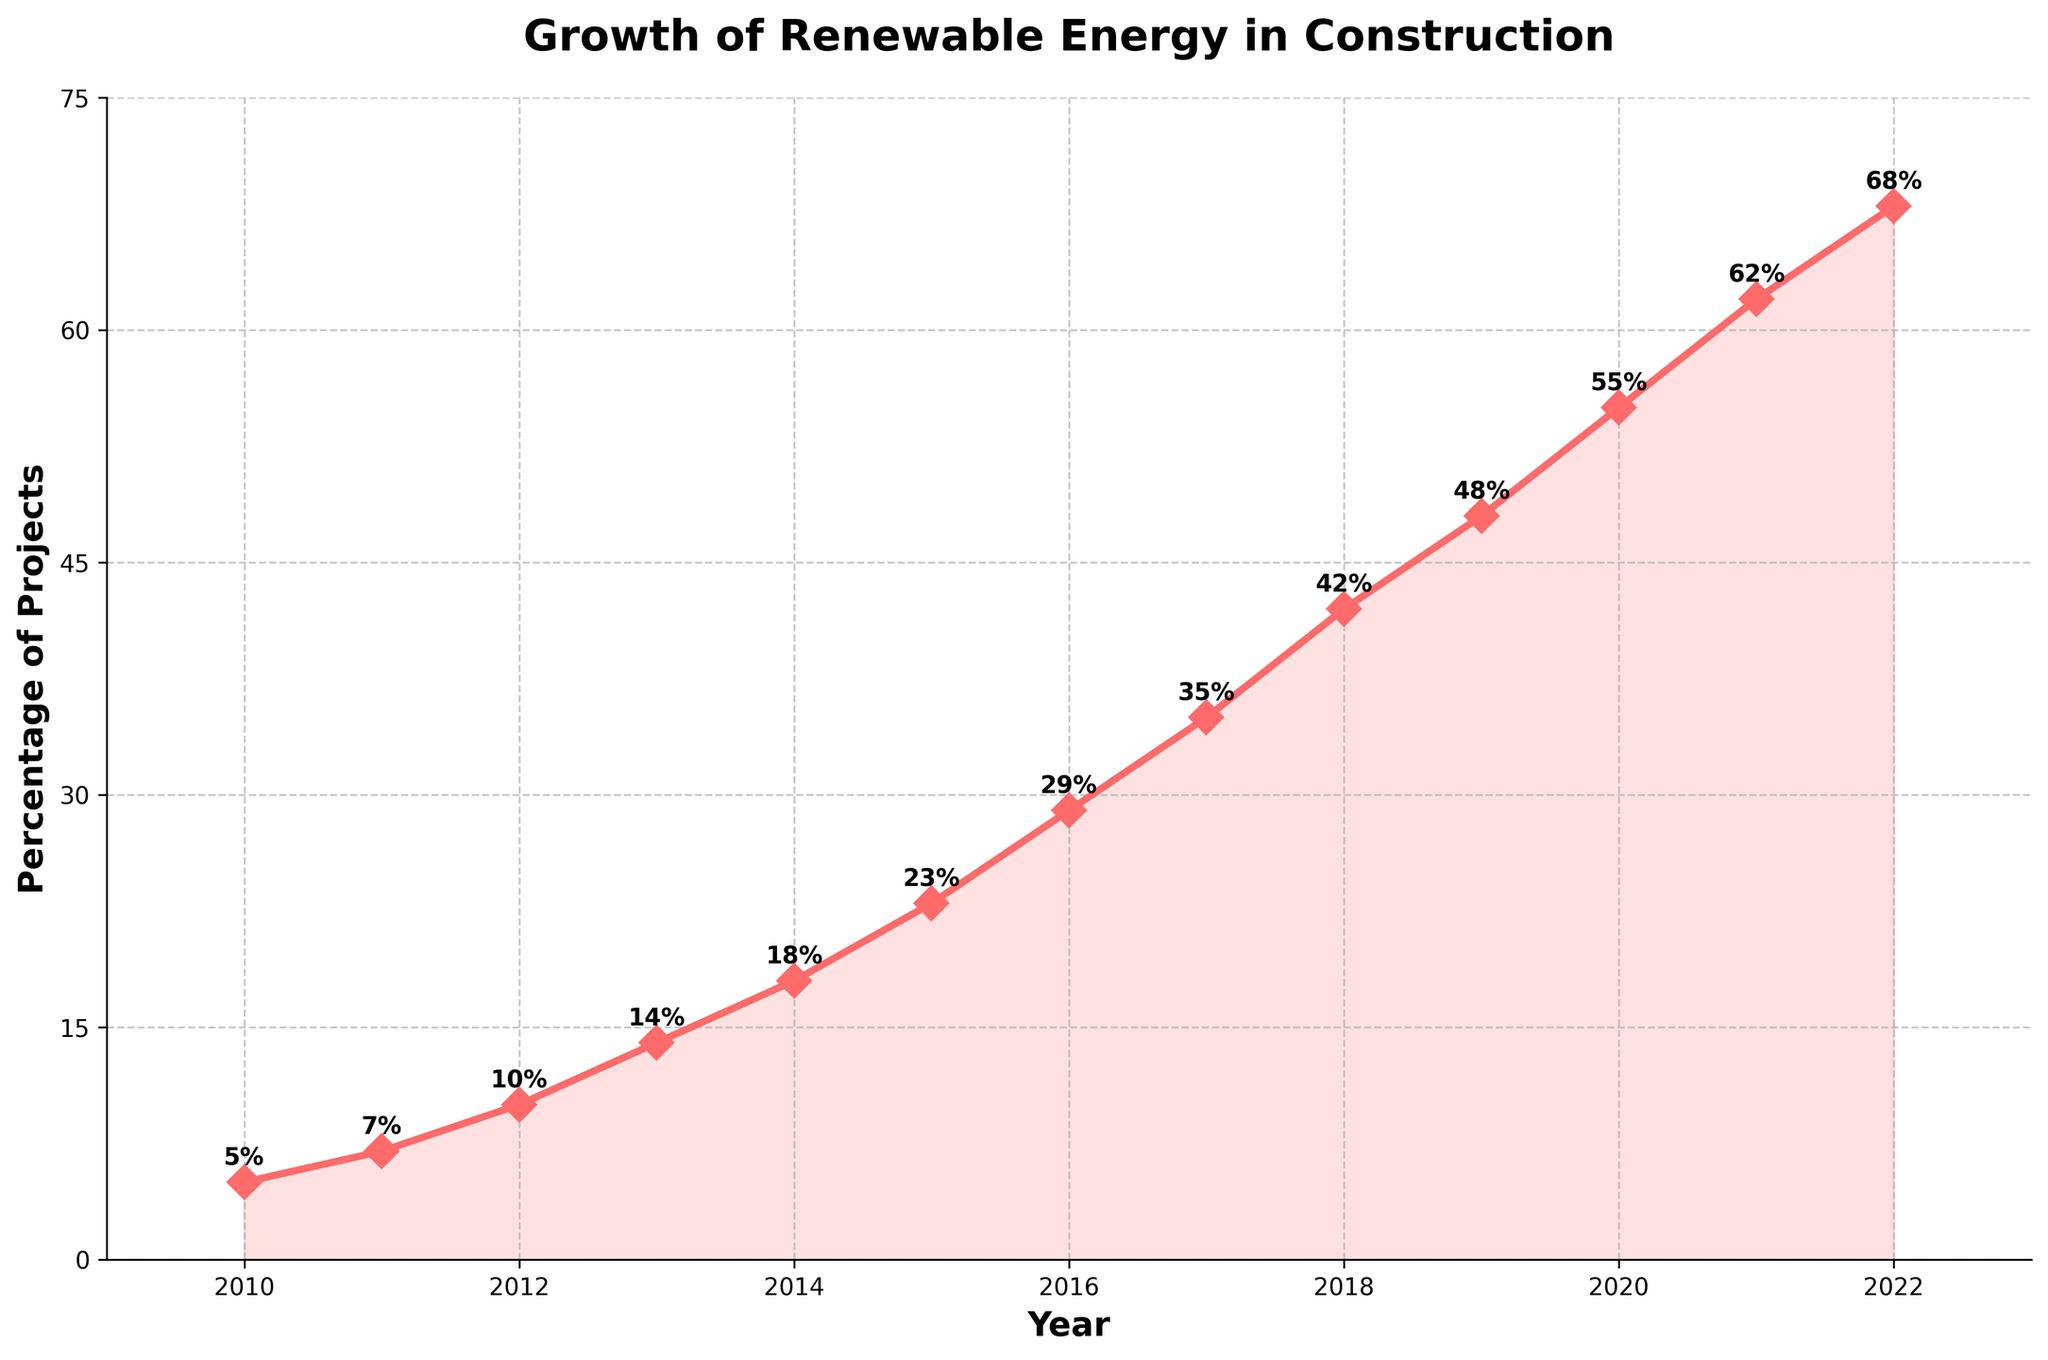What year saw the highest percentage of new construction projects with renewable energy installations? The highest point on the trend line indicates the maximum percentage. The annotation at the highest point shows 68% in 2022.
Answer: 2022 How much did the percentage increase from 2010 to 2020? Subtract the percentage in 2010 (5%) from the percentage in 2020 (55%). 55% - 5% = 50%.
Answer: 50% What was the average percentage of new construction projects with renewable energy installations from 2010 to 2015? Add the percentages for 2010 to 2015 and divide by the number of years: (5 + 7 + 10 + 14 + 18 + 23) / 6 = 77 / 6 ≈ 12.83%.
Answer: 12.83% In which year did the percentage first exceed 30%? Find the year where the percentage first exceeds 30% by looking at the data points. The first year above 30% is 2016 with 29% in 2015 and 35% in 2017.
Answer: 2017 Which two consecutive years saw the largest increase in the percentage of projects? Compare the increase between each pair of consecutive years; 2017 to 2018 shows the largest jump: 42% - 35% = 7%. Check for other increases: 2016-2017 (6%), 2018-2019 (6%), etc., confirming the largest increase is 7%.
Answer: 2017-2018 How did the percentage change between 2014 and 2015? Subtract the percentage in 2014 (18%) from the percentage in 2015 (23%): 23% - 18% = 5%.
Answer: 5% Are there any years where the percentage did not increase compared to the previous year? By observing the upward trend line, each year shows an increase compared to the previous year.
Answer: No By how much did the percentage change on average from year to year between 2010 and 2022? Calculate the total increase over the period (68% - 5%) and then divide by the number of intervals (12): (68% - 5%) / 12 ≈ 5.25%.
Answer: 5.25% What is the percentage difference between 2013 and 2018? Subtract the percentage in 2013 (14%) from the percentage in 2018 (42%): 42% - 14% = 28%.
Answer: 28% In what year did the percentage first reach at least 50%? Identify the year when the percentage first reaches or exceeds 50%, which occurs in 2020 with 55%.
Answer: 2020 